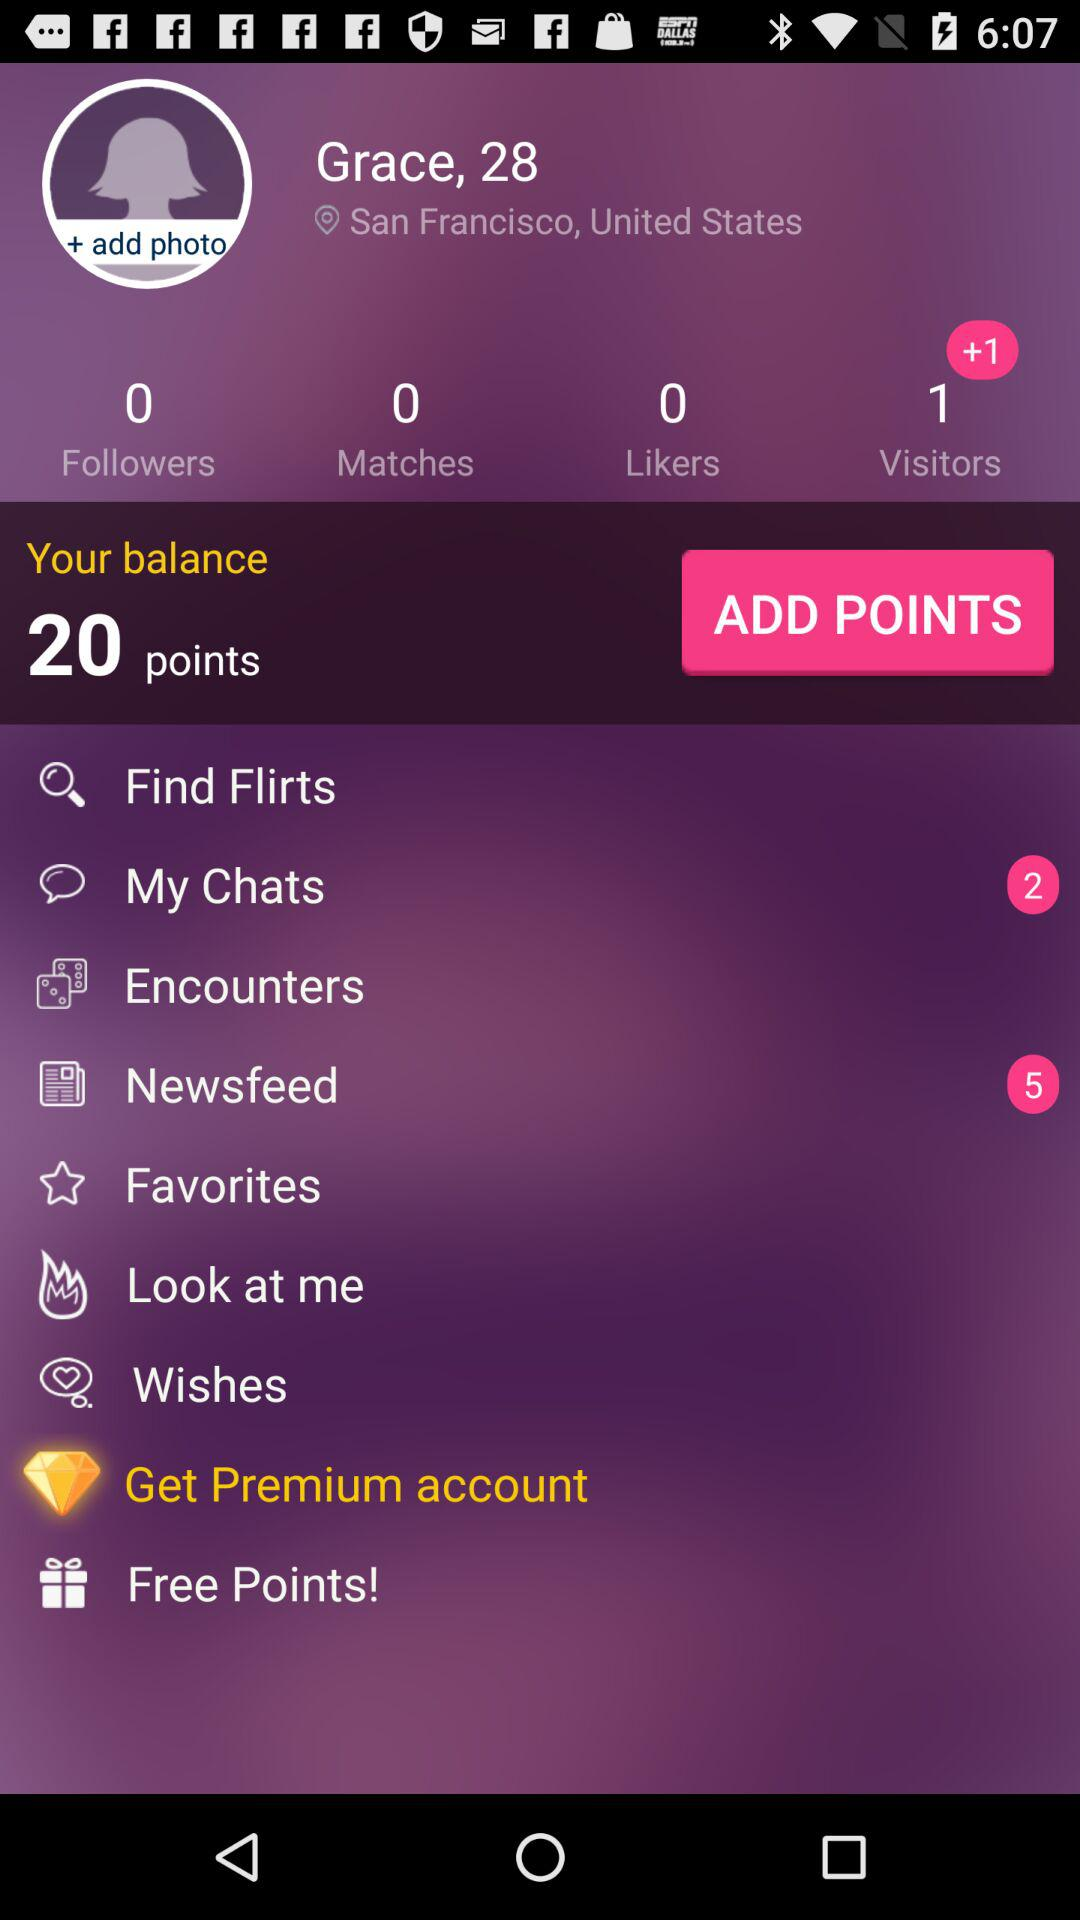What's the user's profile name? The user's profile name is Grace. 